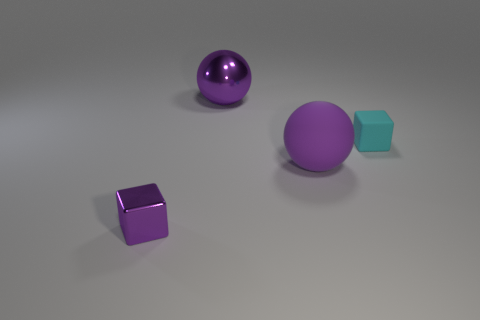Is the shape of the large matte thing the same as the large shiny object?
Provide a short and direct response. Yes. The sphere that is in front of the tiny rubber thing is what color?
Provide a succinct answer. Purple. Is the purple shiny cube the same size as the rubber block?
Offer a very short reply. Yes. What is the size of the purple shiny block?
Offer a very short reply. Small. There is a small shiny object that is the same color as the matte sphere; what shape is it?
Your answer should be very brief. Cube. Is the number of matte objects greater than the number of tiny purple objects?
Provide a succinct answer. Yes. There is a small metal cube that is in front of the tiny object right of the cube that is on the left side of the purple metallic ball; what color is it?
Your response must be concise. Purple. Do the small object left of the metal sphere and the small cyan object have the same shape?
Offer a terse response. Yes. What color is the object that is the same size as the purple matte ball?
Provide a short and direct response. Purple. How many red objects are there?
Keep it short and to the point. 0. 